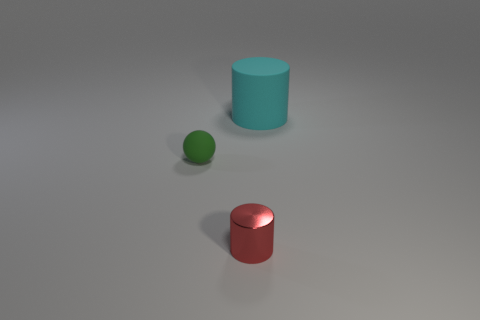Are there any other things that have the same material as the red cylinder?
Give a very brief answer. No. What number of matte things are the same color as the big matte cylinder?
Ensure brevity in your answer.  0. There is a object that is right of the small rubber thing and behind the red cylinder; what is its shape?
Your answer should be compact. Cylinder. There is a object that is behind the small red cylinder and to the right of the green thing; what is its color?
Offer a very short reply. Cyan. Are there more metallic cylinders that are behind the ball than small red metal things that are in front of the big object?
Make the answer very short. No. There is a cylinder behind the green rubber thing; what color is it?
Offer a terse response. Cyan. There is a matte object to the left of the tiny metallic cylinder; is it the same shape as the matte object right of the small red cylinder?
Offer a terse response. No. Are there any cyan things that have the same size as the cyan cylinder?
Give a very brief answer. No. What is the material of the thing that is left of the small red object?
Keep it short and to the point. Rubber. Are the tiny thing that is in front of the green thing and the small ball made of the same material?
Provide a short and direct response. No. 